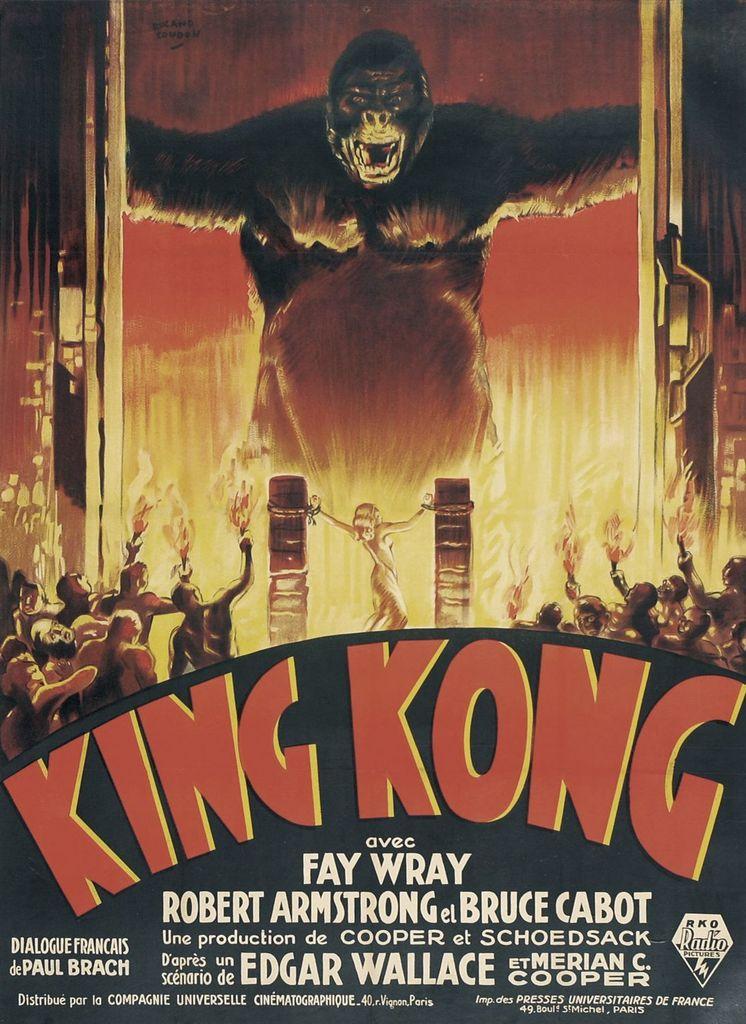What is the name of the movie?
Your answer should be very brief. King kong. Who is an actress in the movie?
Keep it short and to the point. Fay wray. 